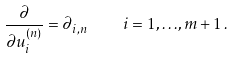<formula> <loc_0><loc_0><loc_500><loc_500>\frac { \partial } { \partial u ^ { ( n ) } _ { i } } = \partial _ { i , n } \quad i = 1 , { \dots } , m + 1 \, .</formula> 